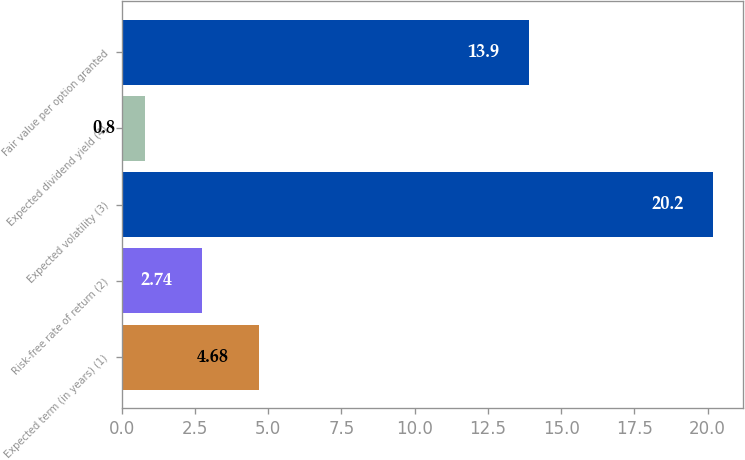Convert chart to OTSL. <chart><loc_0><loc_0><loc_500><loc_500><bar_chart><fcel>Expected term (in years) (1)<fcel>Risk-free rate of return (2)<fcel>Expected volatility (3)<fcel>Expected dividend yield (4)<fcel>Fair value per option granted<nl><fcel>4.68<fcel>2.74<fcel>20.2<fcel>0.8<fcel>13.9<nl></chart> 